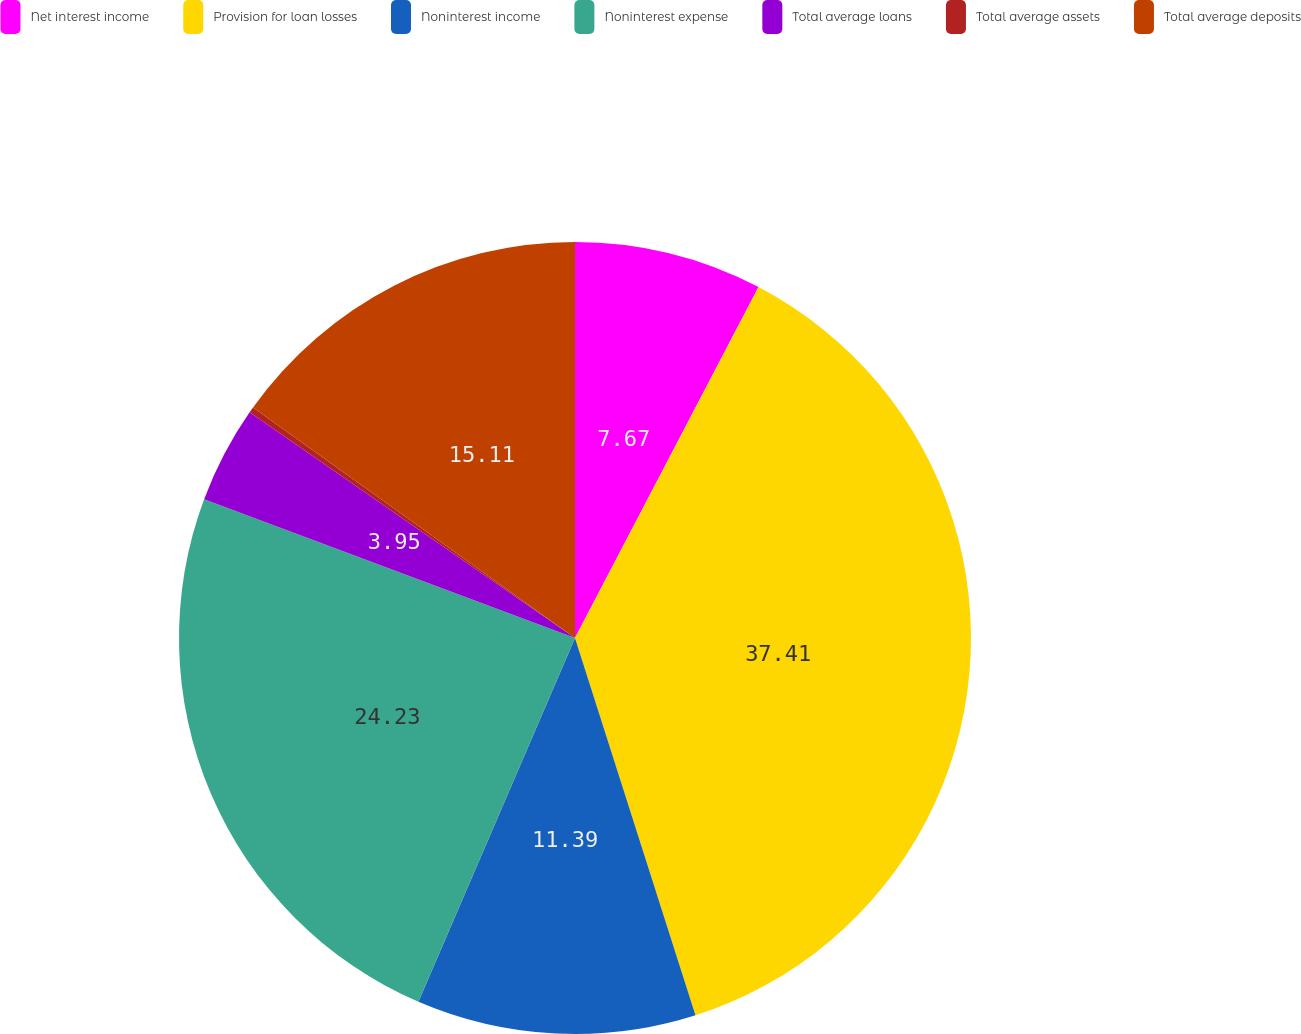Convert chart. <chart><loc_0><loc_0><loc_500><loc_500><pie_chart><fcel>Net interest income<fcel>Provision for loan losses<fcel>Noninterest income<fcel>Noninterest expense<fcel>Total average loans<fcel>Total average assets<fcel>Total average deposits<nl><fcel>7.67%<fcel>37.41%<fcel>11.39%<fcel>24.23%<fcel>3.95%<fcel>0.24%<fcel>15.11%<nl></chart> 